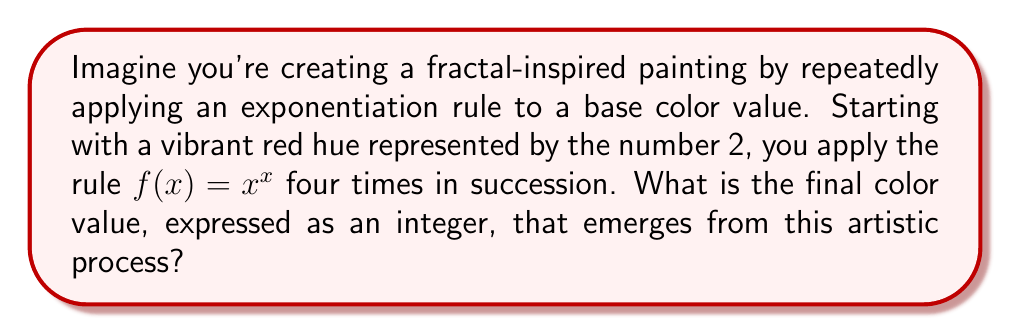Solve this math problem. Let's follow the artistic journey of color transformation step by step:

1) We start with the base color value of 2.

2) First application:
   $f(2) = 2^2 = 4$

3) Second application:
   $f(4) = 4^4 = 256$

4) Third application:
   $f(256) = 256^{256}$
   This is an enormously large number. Let's calculate it:
   $256 = 2^8$
   So, $256^{256} = (2^8)^{256} = 2^{8 \times 256} = 2^{2048}$

5) Fourth and final application:
   $f(2^{2048}) = (2^{2048})^{(2^{2048})}$
   This can be written as:
   $2^{2048 \times 2^{2048}}$

The result is an incredibly large number, far beyond what we can practically compute or represent. It's a number with approximately $10^{616}$ digits, which is more than the number of atoms in the observable universe.

This exponential growth mirrors the self-replicating, intricate patterns found in fractals, where each iteration leads to increasingly complex structures.
Answer: $2^{2048 \times 2^{2048}}$ 